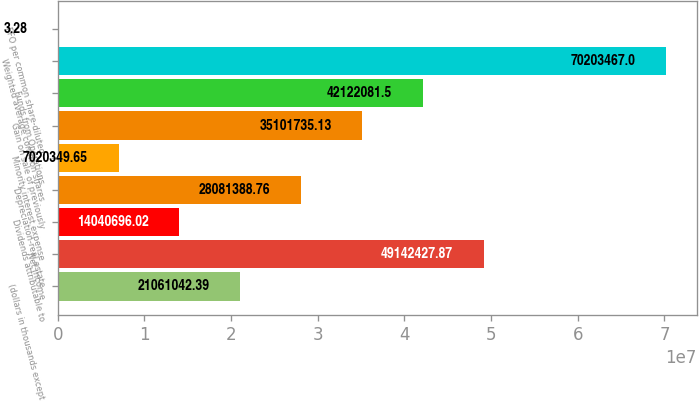Convert chart. <chart><loc_0><loc_0><loc_500><loc_500><bar_chart><fcel>(dollars in thousands except<fcel>Net income<fcel>Dividends attributable to<fcel>Depreciation-real estate<fcel>Minority interest expense<fcel>Gain on sale of previously<fcel>Funds from Operations<fcel>Weighted average common shares<fcel>FFO per common share-diluted<nl><fcel>2.1061e+07<fcel>4.91424e+07<fcel>1.40407e+07<fcel>2.80814e+07<fcel>7.02035e+06<fcel>3.51017e+07<fcel>4.21221e+07<fcel>7.02035e+07<fcel>3.28<nl></chart> 